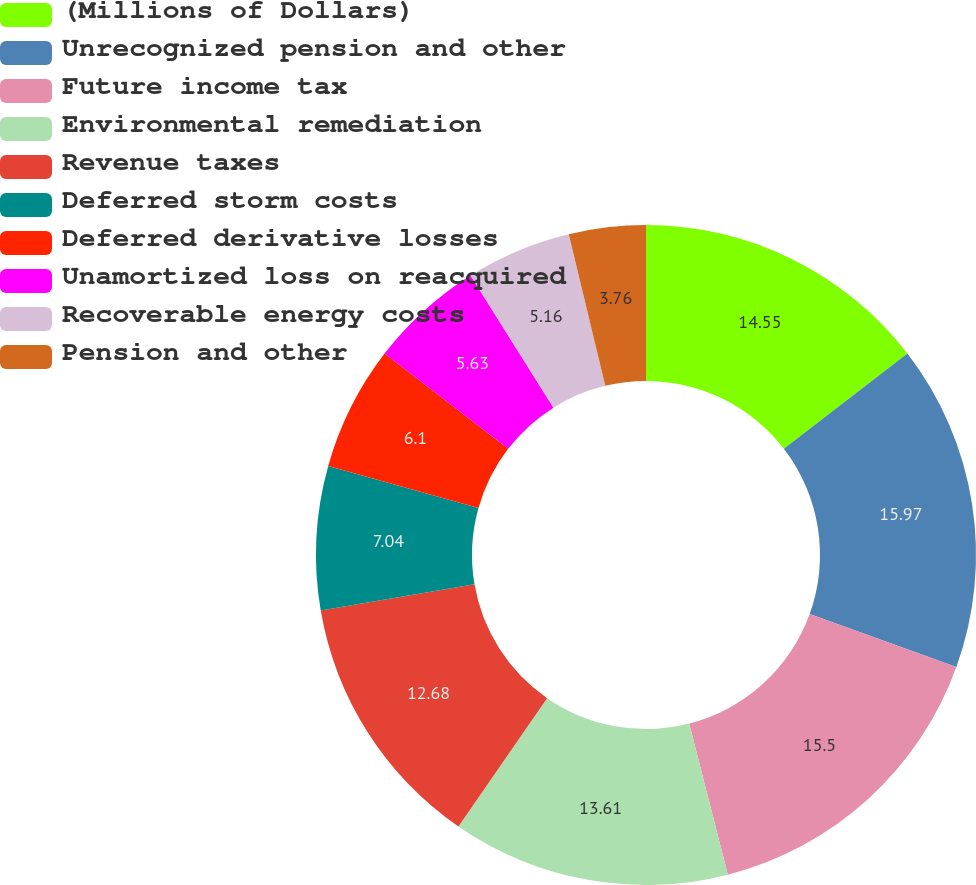Convert chart to OTSL. <chart><loc_0><loc_0><loc_500><loc_500><pie_chart><fcel>(Millions of Dollars)<fcel>Unrecognized pension and other<fcel>Future income tax<fcel>Environmental remediation<fcel>Revenue taxes<fcel>Deferred storm costs<fcel>Deferred derivative losses<fcel>Unamortized loss on reacquired<fcel>Recoverable energy costs<fcel>Pension and other<nl><fcel>14.55%<fcel>15.96%<fcel>15.49%<fcel>13.61%<fcel>12.68%<fcel>7.04%<fcel>6.1%<fcel>5.63%<fcel>5.16%<fcel>3.76%<nl></chart> 